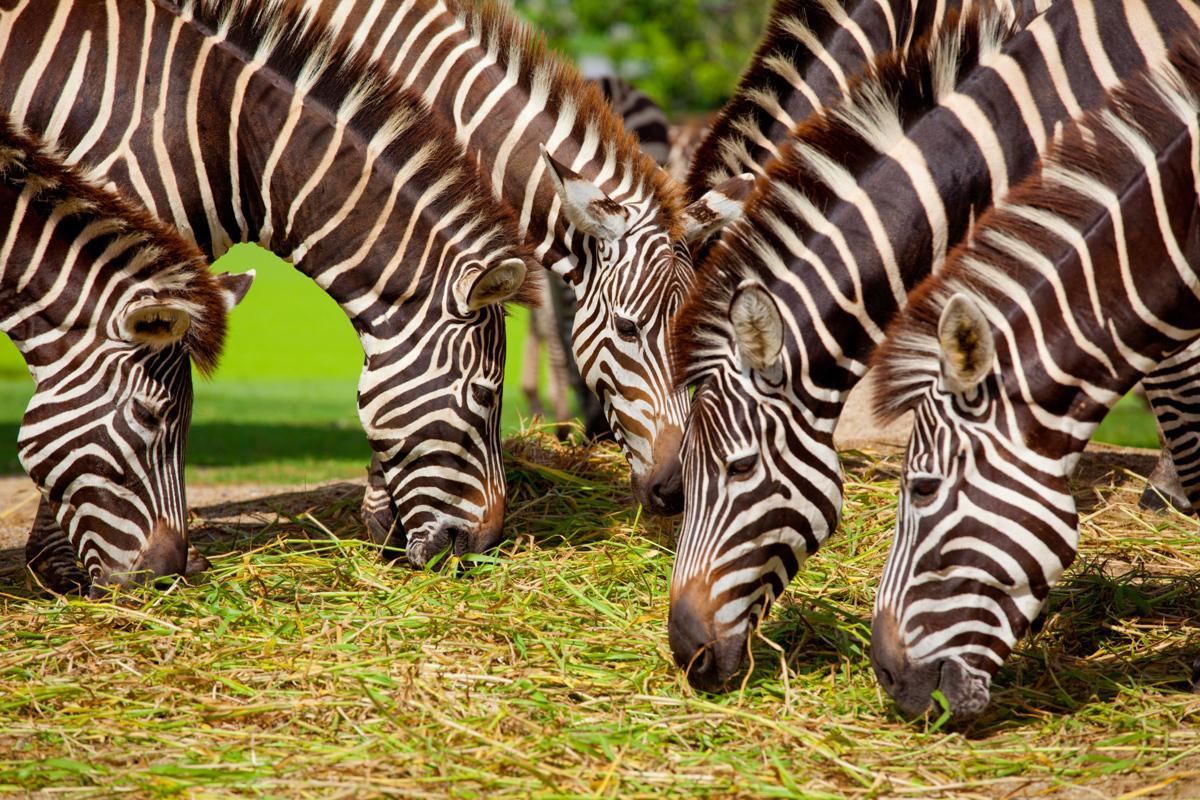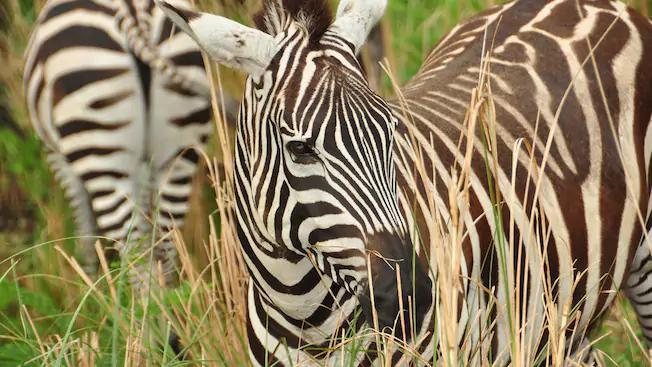The first image is the image on the left, the second image is the image on the right. Analyze the images presented: Is the assertion "The left and right image contains the same number of zebras." valid? Answer yes or no. No. The first image is the image on the left, the second image is the image on the right. Given the left and right images, does the statement "The combined images include at least four zebras standing in profile with heads and necks curved to the ground." hold true? Answer yes or no. Yes. 